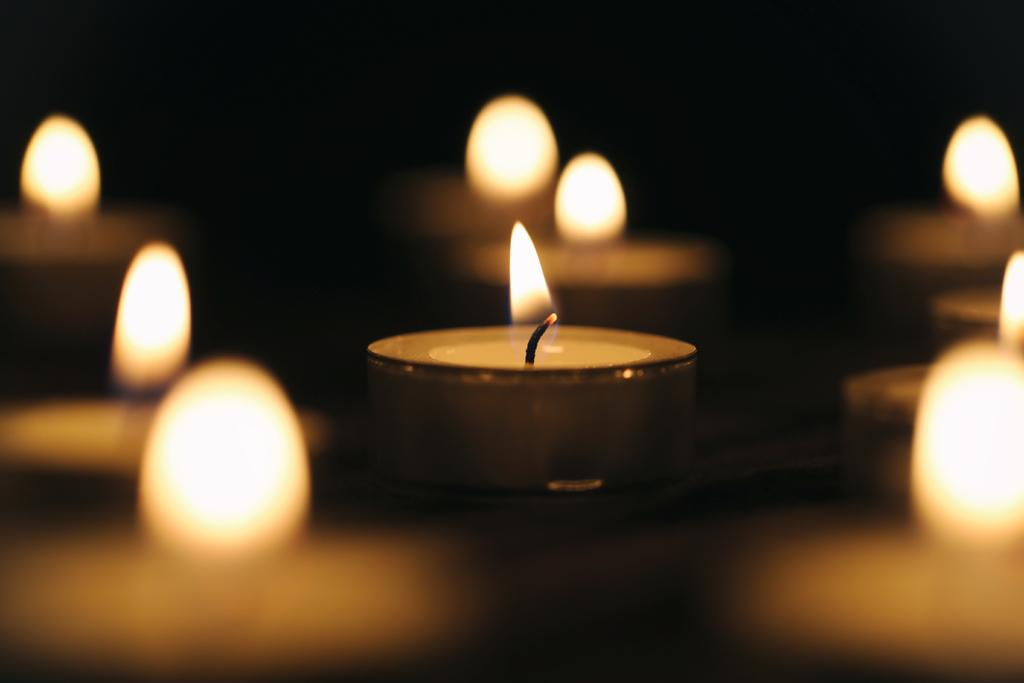What objects are present in the image? There are candles in the image. Can you describe the candles in more detail? Unfortunately, the provided facts do not offer any additional details about the candles. Are there any other objects or elements in the image besides the candles? No additional information is provided about other objects or elements in the image. What type of desk is visible in the image? There is no desk present in the image; only candles are mentioned. How are the candles being distributed in the image? The provided facts do not offer any information about the distribution of the candles. Can you hear any sounds coming from the candles in the image? The provided facts do not offer any information about sounds or the presence of ears in the image. 